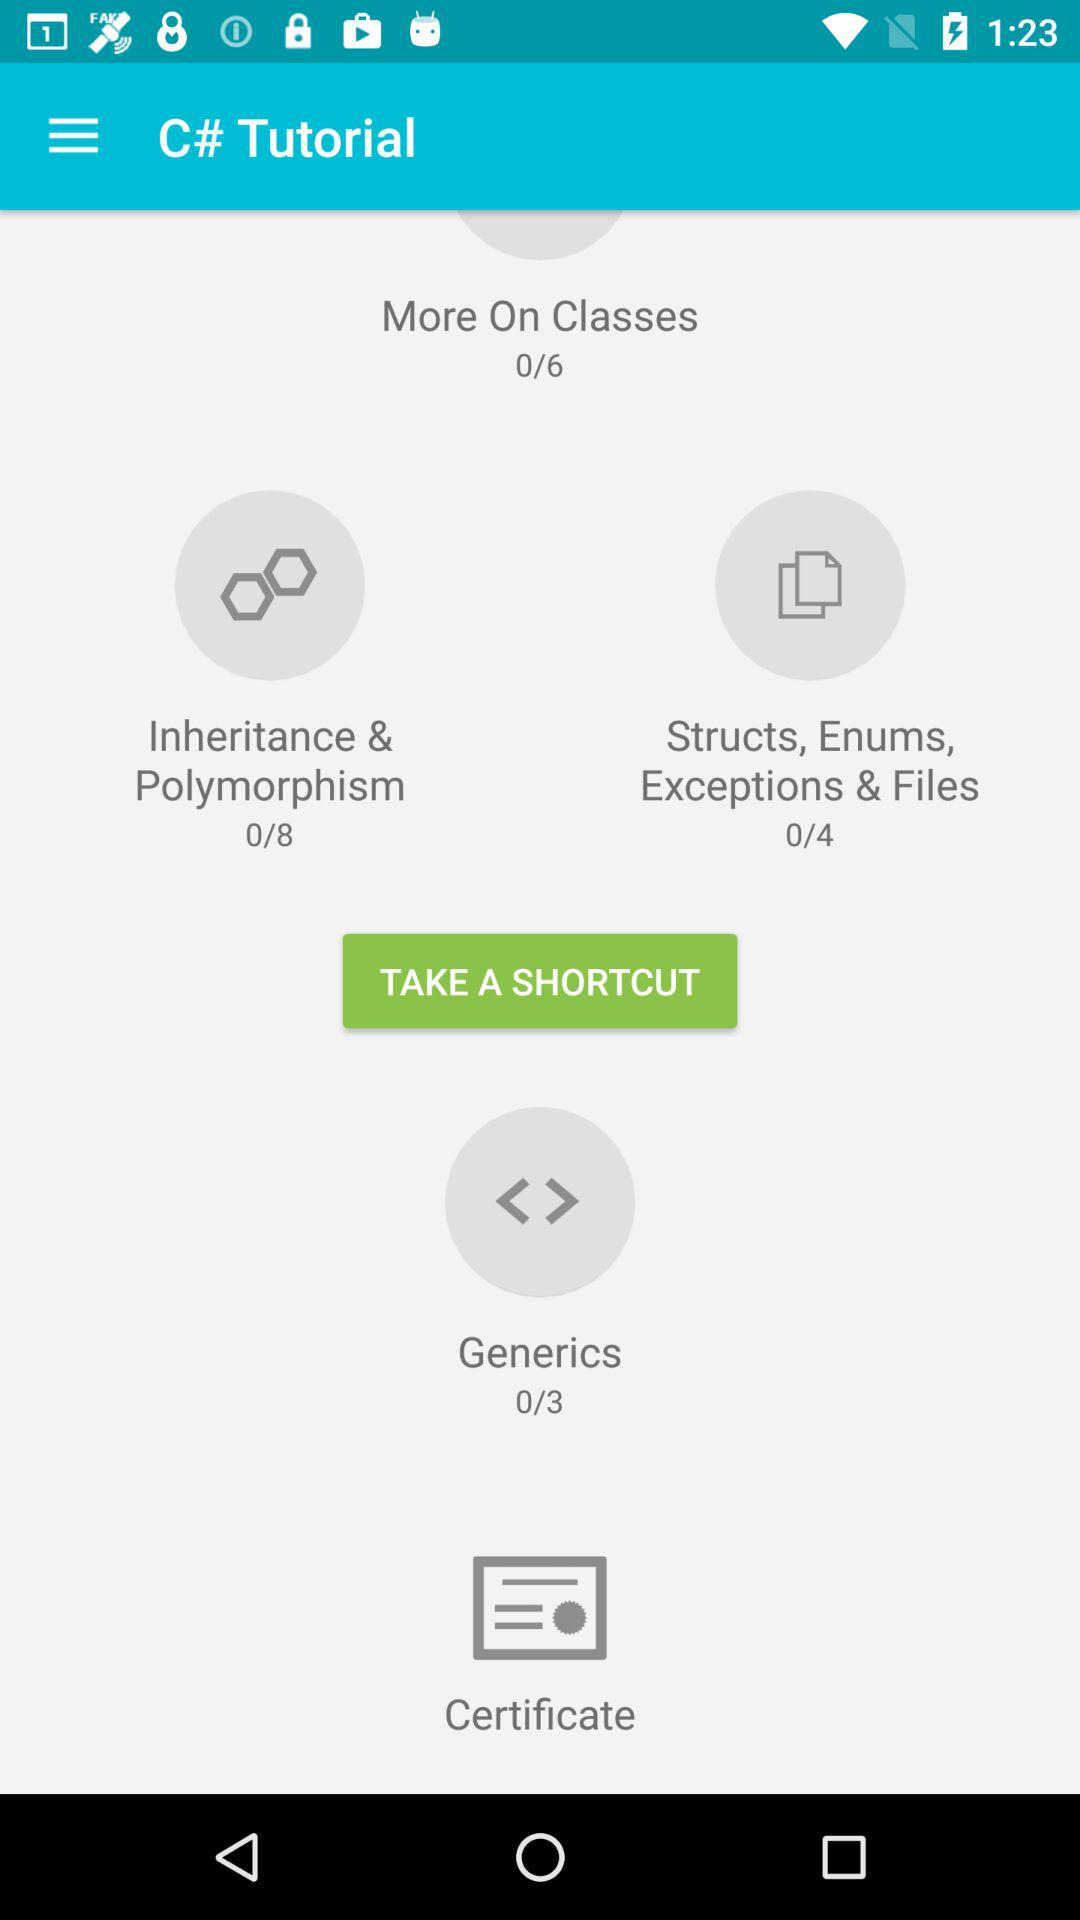What is the total number of tutorials in "More On Classes"? The total number of tutorials in "More On Classes" is 6. 